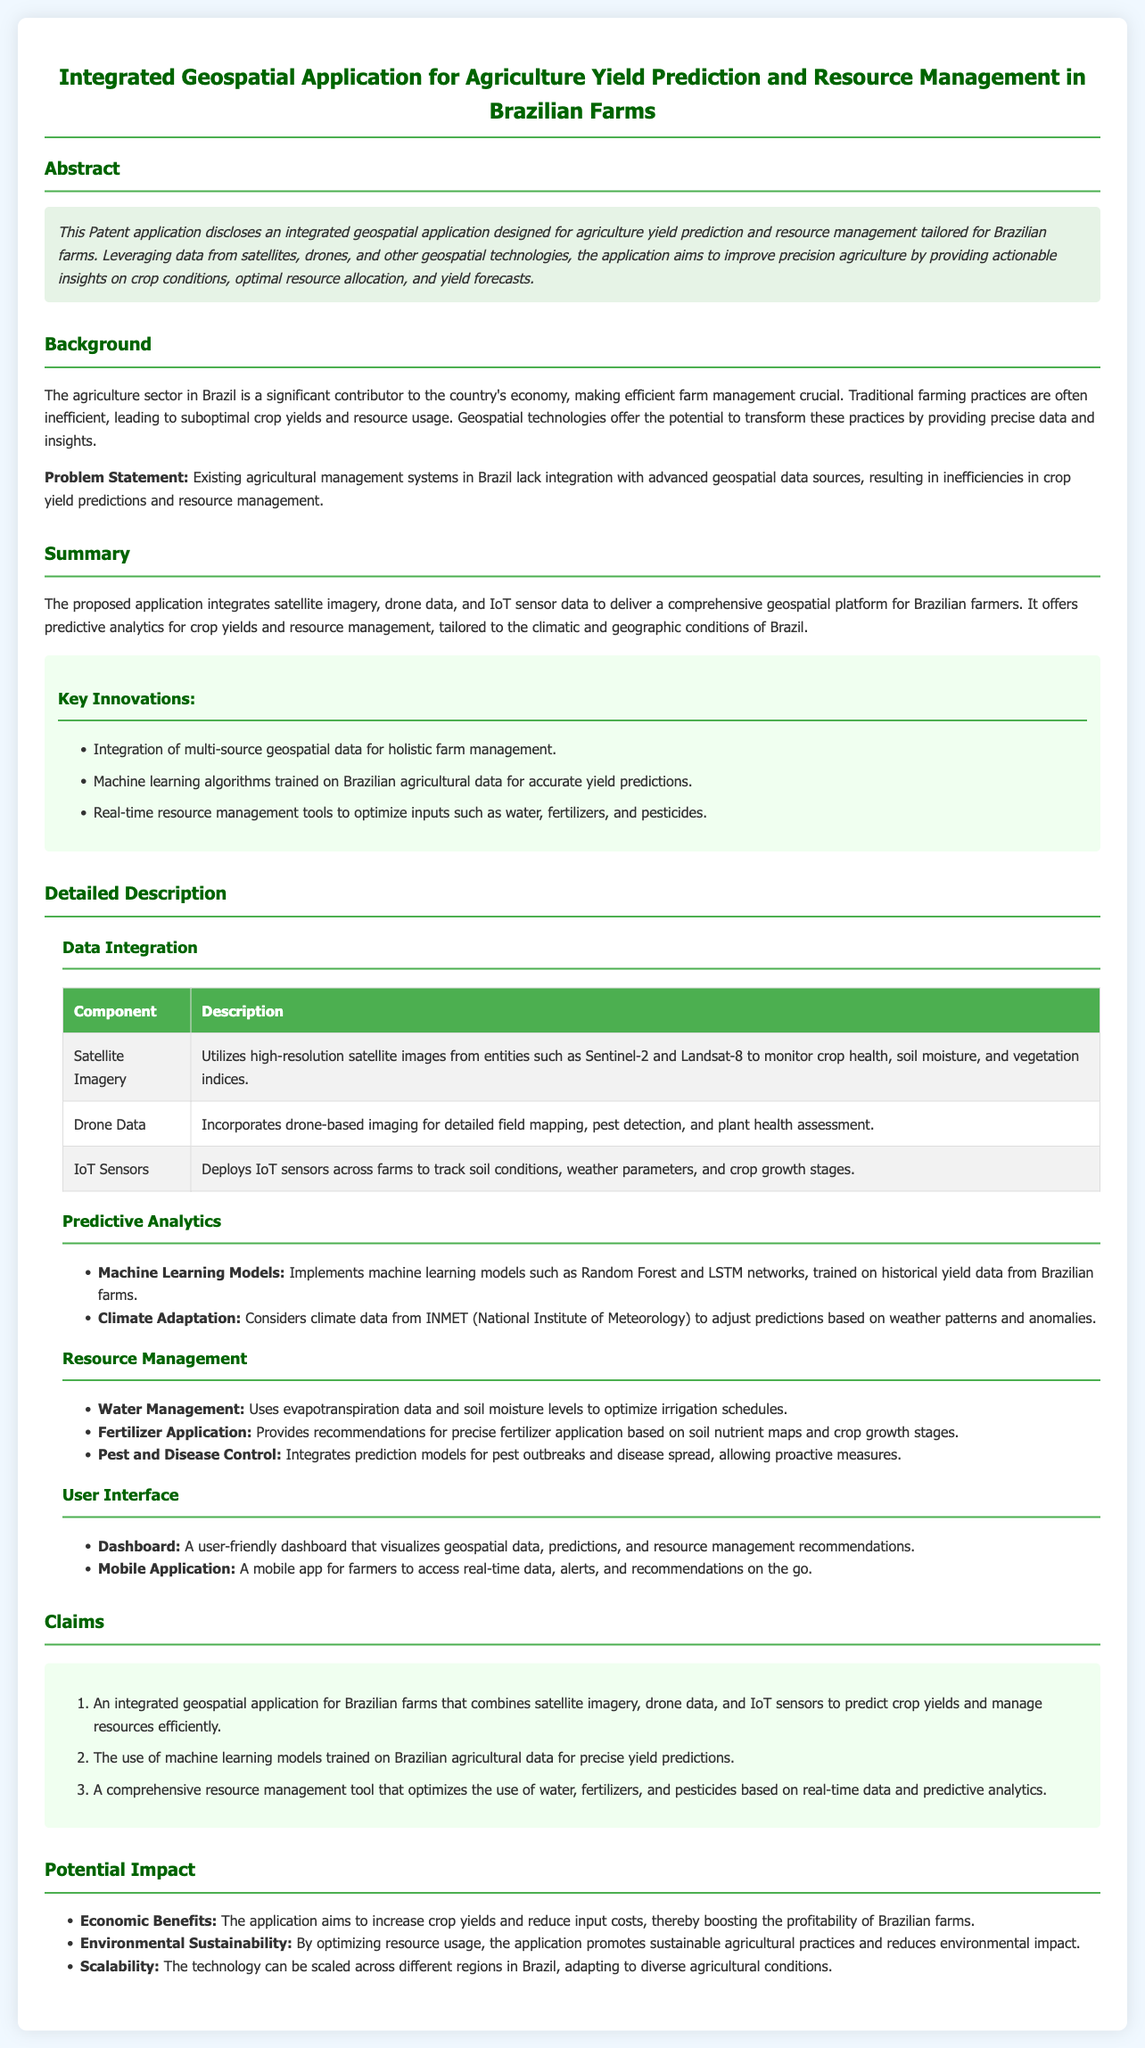What is the main focus of the patent application? The abstract states that the patent application focuses on an integrated geospatial application for agriculture yield prediction and resource management tailored for Brazilian farms.
Answer: agriculture yield prediction and resource management What technologies does the application utilize? The summary section mentions that the application integrates satellite imagery, drone data, and IoT sensor data.
Answer: satellite imagery, drone data, IoT sensor data Which machine learning models are implemented in the application? The Detailed Description mentions that Random Forest and LSTM networks are the machine learning models implemented for predictions.
Answer: Random Forest and LSTM networks What are the three key innovations mentioned in the document? The key innovations section lists integration of multi-source geospatial data, machine learning algorithms, and real-time resource management tools.
Answer: multi-source geospatial data, machine learning algorithms, real-time resource management tools What impact does the application aim to have on economic benefits? The Potential Impact section states that the application aims to increase crop yields and reduce input costs, boosting the profitability of farms.
Answer: increase crop yields and reduce input costs What is the role of IoT sensors in the application? According to the data integration description, IoT sensors deploy across farms to track soil conditions, weather parameters, and crop growth stages.
Answer: track soil conditions, weather parameters, and crop growth stages How does the application help with water management? The resource management section describes that the application uses evapotranspiration data and soil moisture levels to optimize irrigation schedules.
Answer: optimize irrigation schedules What problem does the application address in Brazilian agriculture? The problem statement mentions that existing agricultural management systems lack integration with advanced geospatial data sources, causing inefficiencies.
Answer: lack integration with advanced geospatial data sources What is the user-friendly feature mentioned for farmers? The user interface section mentions a mobile app for farmers to access real-time data, alerts, and recommendations.
Answer: mobile app for farmers to access real-time data 